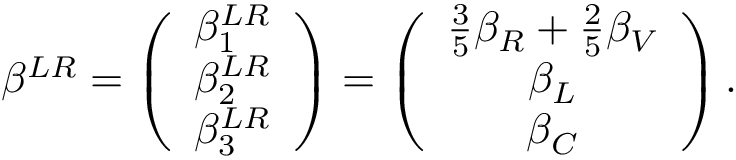<formula> <loc_0><loc_0><loc_500><loc_500>\beta ^ { L R } = \left ( \begin{array} { c } { { \beta _ { 1 } ^ { L R } } } \\ { { \beta _ { 2 } ^ { L R } } } \\ { { \beta _ { 3 } ^ { L R } } } \end{array} \right ) = \left ( \begin{array} { c } { { \frac { 3 } { 5 } \beta _ { R } + \frac { 2 } { 5 } \beta _ { V } } } \\ { { \beta _ { L } } } \\ { { \beta _ { C } } } \end{array} \right ) .</formula> 